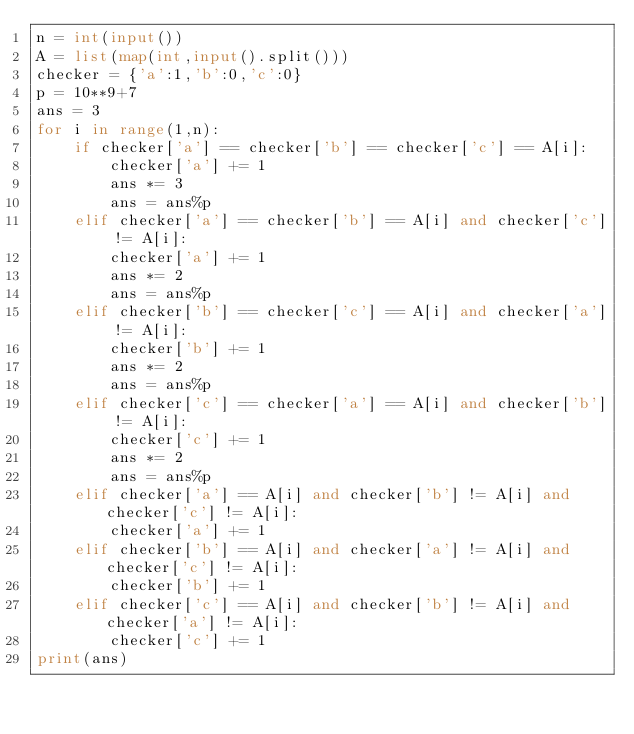Convert code to text. <code><loc_0><loc_0><loc_500><loc_500><_Python_>n = int(input())
A = list(map(int,input().split()))
checker = {'a':1,'b':0,'c':0}
p = 10**9+7
ans = 3
for i in range(1,n):
    if checker['a'] == checker['b'] == checker['c'] == A[i]:
        checker['a'] += 1
        ans *= 3
        ans = ans%p
    elif checker['a'] == checker['b'] == A[i] and checker['c'] != A[i]:
        checker['a'] += 1
        ans *= 2
        ans = ans%p
    elif checker['b'] == checker['c'] == A[i] and checker['a'] != A[i]:
        checker['b'] += 1
        ans *= 2
        ans = ans%p
    elif checker['c'] == checker['a'] == A[i] and checker['b'] != A[i]:
        checker['c'] += 1
        ans *= 2
        ans = ans%p
    elif checker['a'] == A[i] and checker['b'] != A[i] and checker['c'] != A[i]:
        checker['a'] += 1
    elif checker['b'] == A[i] and checker['a'] != A[i] and checker['c'] != A[i]:
        checker['b'] += 1
    elif checker['c'] == A[i] and checker['b'] != A[i] and checker['a'] != A[i]:
        checker['c'] += 1
print(ans)</code> 